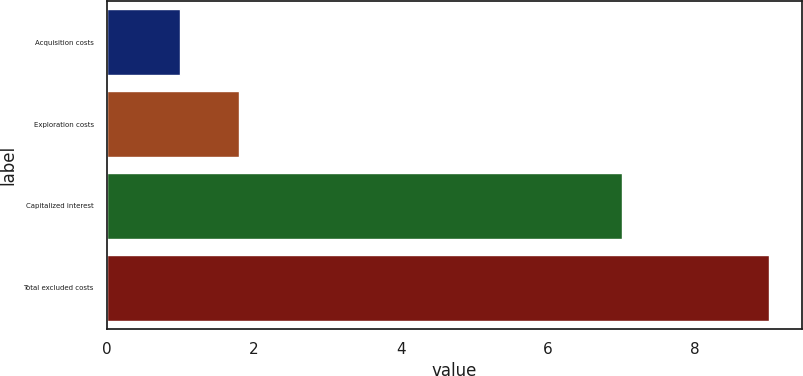Convert chart to OTSL. <chart><loc_0><loc_0><loc_500><loc_500><bar_chart><fcel>Acquisition costs<fcel>Exploration costs<fcel>Capitalized interest<fcel>Total excluded costs<nl><fcel>1<fcel>1.8<fcel>7<fcel>9<nl></chart> 